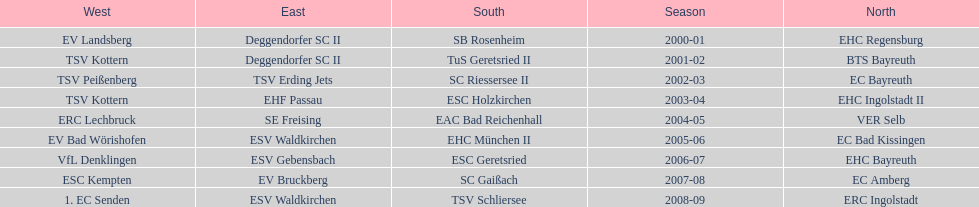Starting with the 2007 - 08 season, does ecs kempten appear in any of the previous years? No. 